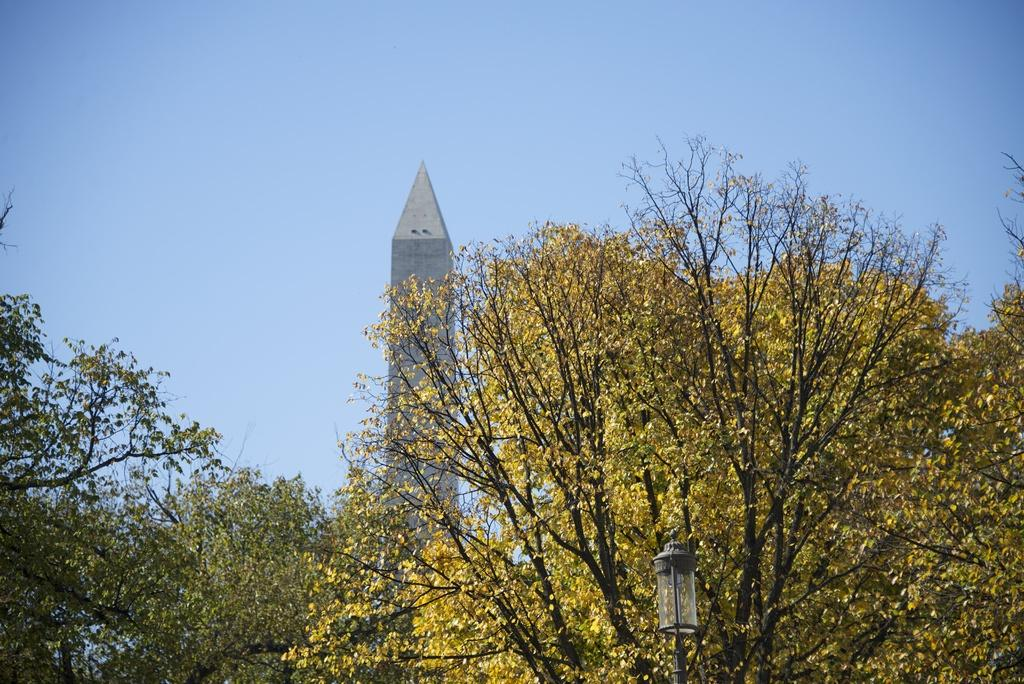What type of natural elements can be seen in the image? There are many trees in the image. What man-made object is present in the image? There is a light pole in the image. Can you describe the tower in the image? The tower in the image is ash-colored. What color is the sky in the background of the image? The sky is blue in the background of the image. What type of feast is being prepared in the image? There is no indication of a feast or any food preparation in the image. What type of society is depicted in the image? The image does not depict a society; it primarily features trees, a light pole, a tower, and the sky. 